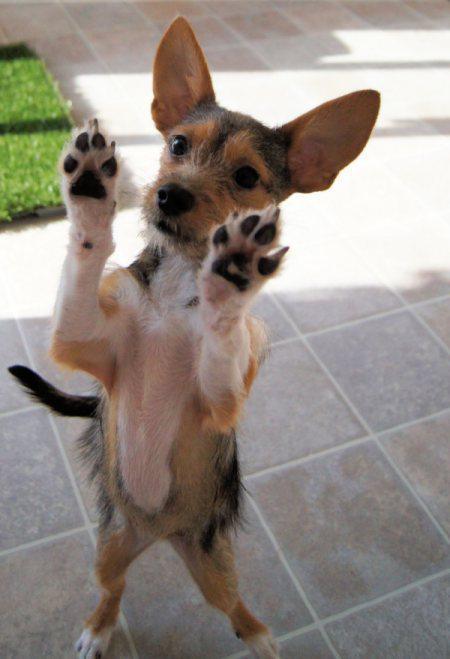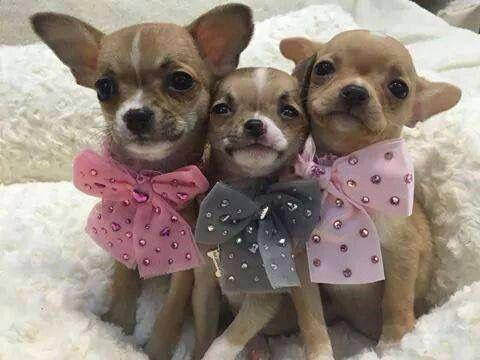The first image is the image on the left, the second image is the image on the right. For the images shown, is this caption "There are 3 dogs in the image pair" true? Answer yes or no. No. The first image is the image on the left, the second image is the image on the right. Examine the images to the left and right. Is the description "At least one dog is wearing a bowtie." accurate? Answer yes or no. Yes. 